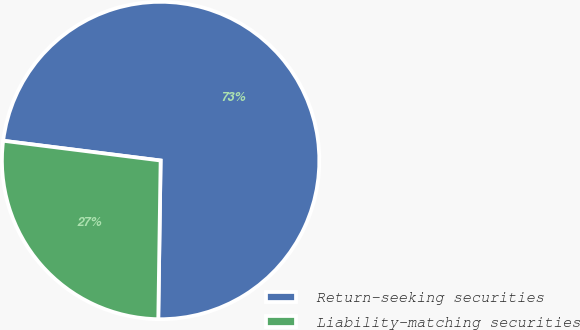Convert chart. <chart><loc_0><loc_0><loc_500><loc_500><pie_chart><fcel>Return-seeking securities<fcel>Liability-matching securities<nl><fcel>73.25%<fcel>26.75%<nl></chart> 